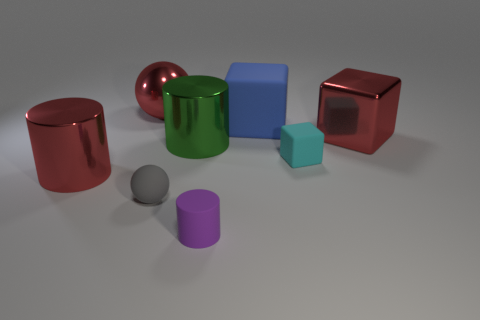Subtract 1 cylinders. How many cylinders are left? 2 Add 1 purple objects. How many objects exist? 9 Subtract all spheres. How many objects are left? 6 Subtract 0 purple blocks. How many objects are left? 8 Subtract all small cyan cubes. Subtract all matte blocks. How many objects are left? 5 Add 1 tiny cyan matte blocks. How many tiny cyan matte blocks are left? 2 Add 2 metallic balls. How many metallic balls exist? 3 